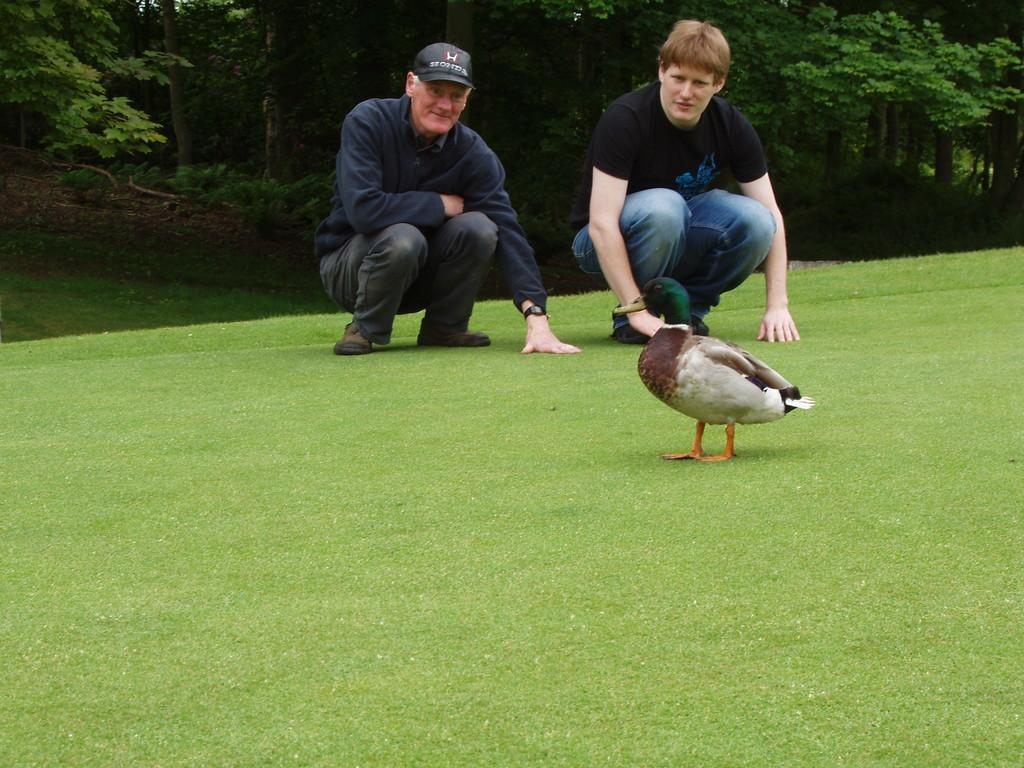How many people are present in the image? There are two persons in the image. Can you describe the clothing of one of the persons? One person is wearing a cap. What is on the ground in the image? There is a bird on the ground. What can be seen in the background of the image? There are trees and plants in the background of the image. What type of books can be seen on the persons in the image? There are no books present in the image. What is the aftermath of the division between the two persons in the image? There is no division between the two persons in the image, and therefore no aftermath can be observed. 